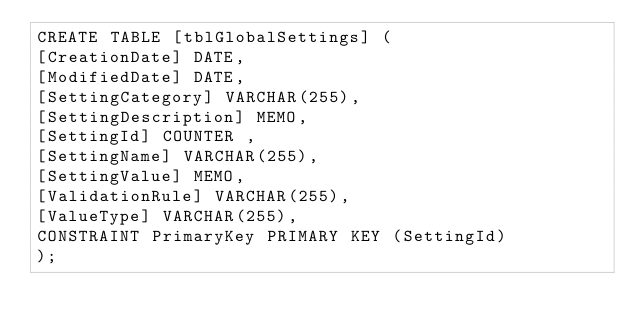Convert code to text. <code><loc_0><loc_0><loc_500><loc_500><_SQL_>CREATE TABLE [tblGlobalSettings] ( 
[CreationDate] DATE, 
[ModifiedDate] DATE, 
[SettingCategory] VARCHAR(255), 
[SettingDescription] MEMO, 
[SettingId] COUNTER , 
[SettingName] VARCHAR(255), 
[SettingValue] MEMO, 
[ValidationRule] VARCHAR(255), 
[ValueType] VARCHAR(255), 
CONSTRAINT PrimaryKey PRIMARY KEY (SettingId) 
);</code> 